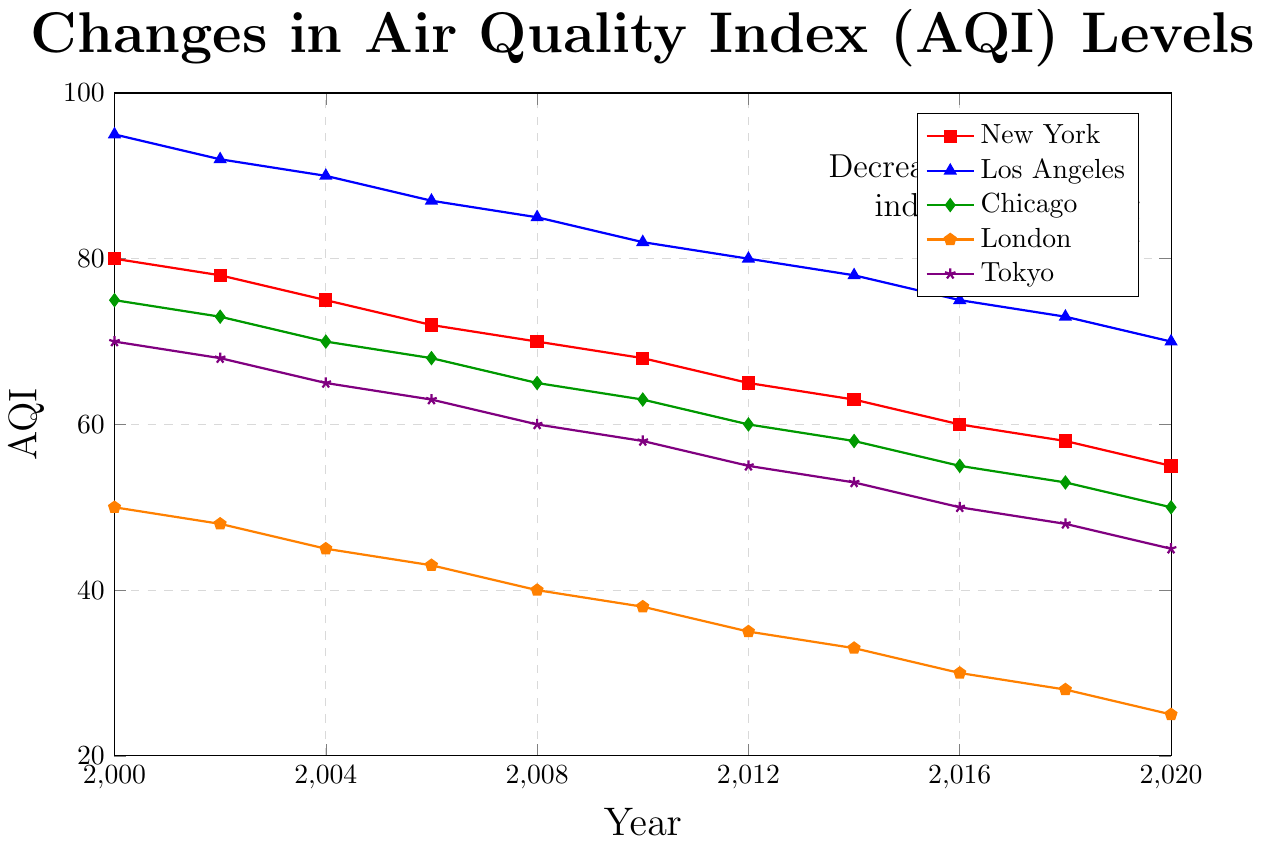Which urban area had the highest AQI in 2000? By examining the starting points for each line in the year 2000, Los Angeles is at the top with an AQI of 95.
Answer: Los Angeles Which urban area showed the greatest improvement in air quality over the two decades? By comparing the starting and ending AQI values from 2000 to 2020, New York decreased from 80 to 55, Los Angeles from 95 to 70, Chicago from 75 to 50, London from 50 to 25, and Tokyo from 70 to 45. London decreased the most (25 points), representing the greatest improvement.
Answer: London What is the average AQI in 2010 for the five cities? Summing the AQI values for 2010 for New York (68), Los Angeles (82), Chicago (63), London (38), and Tokyo (58) gives 68 + 82 + 63 + 38 + 58 = 309. Dividing by 5, the average AQI is 309/5 = 61.8.
Answer: 61.8 Which city had the smallest decline in AQI over the 20 years? Calculating the decline for each city: New York: 80 to 55 (25 points), Los Angeles: 95 to 70 (25 points), Chicago: 75 to 50 (25 points), London: 50 to 25 (25 points), Tokyo: 70 to 45 (25 points). All cities had a decline of 25 points, hence there is no city with a distinct smallest decline.
Answer: All same (25 points) In which year did Tokyo's AQI drop below 60? Observing the trend line for Tokyo, the AQI dropped below 60 between 2008 (60) and 2010 (58). The year when it first dropped below is 2010.
Answer: 2010 Which city consistently had the best air quality over the 20-year period? By checking the lines, London consistently has the lowest AQI from the beginning (50) to the end (25), indicative of the best air quality among the cities listed over the 20-year period.
Answer: London Among the five cities, which one had the lowest AQI in 2016? Looking at the AQI values for 2016, New York: 60, Los Angeles: 75, Chicago: 55, London: 30, Tokyo: 50. London has the lowest AQI of 30.
Answer: London How many years after 2000 did it take for New York's AQI to drop below 70? Considering the trend line for New York, the AQI drops below 70 between 2008 (70) and 2010 (68). Therefore, it took 10 years.
Answer: 10 years What trend is indicated by all the plots on the chart? Observing all the lines, they all show a decreasing trend indicating improving air quality over the two decades.
Answer: Decreasing AQI, improving air quality What was the difference between Los Angeles' AQI and Tokyo's AQI in 2020? By checking the AQI values for 2020, Los Angeles: 70, Tokyo: 45. The difference is 70 - 45 = 25.
Answer: 25 